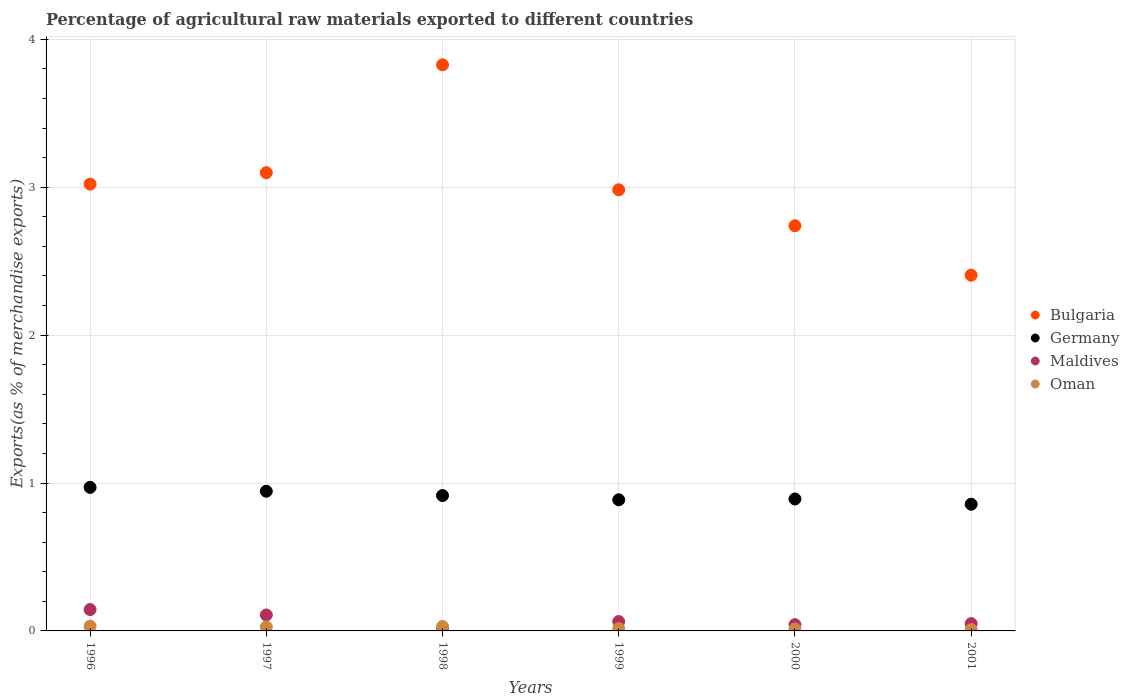How many different coloured dotlines are there?
Ensure brevity in your answer.  4. What is the percentage of exports to different countries in Maldives in 1998?
Your response must be concise. 0.01. Across all years, what is the maximum percentage of exports to different countries in Bulgaria?
Ensure brevity in your answer.  3.83. Across all years, what is the minimum percentage of exports to different countries in Oman?
Your answer should be compact. 0.01. What is the total percentage of exports to different countries in Maldives in the graph?
Offer a terse response. 0.42. What is the difference between the percentage of exports to different countries in Oman in 1996 and that in 1998?
Ensure brevity in your answer.  0. What is the difference between the percentage of exports to different countries in Maldives in 1999 and the percentage of exports to different countries in Bulgaria in 1996?
Make the answer very short. -2.96. What is the average percentage of exports to different countries in Germany per year?
Give a very brief answer. 0.91. In the year 2000, what is the difference between the percentage of exports to different countries in Oman and percentage of exports to different countries in Maldives?
Provide a succinct answer. -0.03. What is the ratio of the percentage of exports to different countries in Bulgaria in 1997 to that in 2001?
Offer a terse response. 1.29. Is the percentage of exports to different countries in Maldives in 2000 less than that in 2001?
Provide a succinct answer. Yes. Is the difference between the percentage of exports to different countries in Oman in 1998 and 2000 greater than the difference between the percentage of exports to different countries in Maldives in 1998 and 2000?
Your answer should be compact. Yes. What is the difference between the highest and the second highest percentage of exports to different countries in Bulgaria?
Keep it short and to the point. 0.73. What is the difference between the highest and the lowest percentage of exports to different countries in Bulgaria?
Your answer should be very brief. 1.42. Is it the case that in every year, the sum of the percentage of exports to different countries in Bulgaria and percentage of exports to different countries in Maldives  is greater than the sum of percentage of exports to different countries in Oman and percentage of exports to different countries in Germany?
Keep it short and to the point. Yes. Is it the case that in every year, the sum of the percentage of exports to different countries in Maldives and percentage of exports to different countries in Germany  is greater than the percentage of exports to different countries in Bulgaria?
Ensure brevity in your answer.  No. Does the percentage of exports to different countries in Germany monotonically increase over the years?
Keep it short and to the point. No. Is the percentage of exports to different countries in Maldives strictly greater than the percentage of exports to different countries in Germany over the years?
Provide a succinct answer. No. What is the difference between two consecutive major ticks on the Y-axis?
Your answer should be compact. 1. Are the values on the major ticks of Y-axis written in scientific E-notation?
Keep it short and to the point. No. Does the graph contain any zero values?
Offer a terse response. No. Where does the legend appear in the graph?
Give a very brief answer. Center right. How are the legend labels stacked?
Provide a short and direct response. Vertical. What is the title of the graph?
Offer a terse response. Percentage of agricultural raw materials exported to different countries. What is the label or title of the X-axis?
Your answer should be very brief. Years. What is the label or title of the Y-axis?
Provide a short and direct response. Exports(as % of merchandise exports). What is the Exports(as % of merchandise exports) in Bulgaria in 1996?
Ensure brevity in your answer.  3.02. What is the Exports(as % of merchandise exports) of Germany in 1996?
Provide a short and direct response. 0.97. What is the Exports(as % of merchandise exports) of Maldives in 1996?
Make the answer very short. 0.14. What is the Exports(as % of merchandise exports) in Oman in 1996?
Offer a terse response. 0.03. What is the Exports(as % of merchandise exports) of Bulgaria in 1997?
Provide a succinct answer. 3.1. What is the Exports(as % of merchandise exports) of Germany in 1997?
Keep it short and to the point. 0.94. What is the Exports(as % of merchandise exports) in Maldives in 1997?
Make the answer very short. 0.11. What is the Exports(as % of merchandise exports) in Oman in 1997?
Ensure brevity in your answer.  0.03. What is the Exports(as % of merchandise exports) in Bulgaria in 1998?
Provide a short and direct response. 3.83. What is the Exports(as % of merchandise exports) in Germany in 1998?
Offer a very short reply. 0.92. What is the Exports(as % of merchandise exports) of Maldives in 1998?
Ensure brevity in your answer.  0.01. What is the Exports(as % of merchandise exports) of Oman in 1998?
Your answer should be compact. 0.03. What is the Exports(as % of merchandise exports) in Bulgaria in 1999?
Offer a terse response. 2.98. What is the Exports(as % of merchandise exports) in Germany in 1999?
Your answer should be compact. 0.89. What is the Exports(as % of merchandise exports) in Maldives in 1999?
Offer a terse response. 0.06. What is the Exports(as % of merchandise exports) of Oman in 1999?
Ensure brevity in your answer.  0.02. What is the Exports(as % of merchandise exports) of Bulgaria in 2000?
Your response must be concise. 2.74. What is the Exports(as % of merchandise exports) of Germany in 2000?
Provide a short and direct response. 0.89. What is the Exports(as % of merchandise exports) in Maldives in 2000?
Your response must be concise. 0.04. What is the Exports(as % of merchandise exports) in Oman in 2000?
Offer a very short reply. 0.01. What is the Exports(as % of merchandise exports) in Bulgaria in 2001?
Offer a terse response. 2.41. What is the Exports(as % of merchandise exports) of Germany in 2001?
Offer a very short reply. 0.86. What is the Exports(as % of merchandise exports) in Maldives in 2001?
Your answer should be very brief. 0.05. What is the Exports(as % of merchandise exports) of Oman in 2001?
Ensure brevity in your answer.  0.01. Across all years, what is the maximum Exports(as % of merchandise exports) in Bulgaria?
Your response must be concise. 3.83. Across all years, what is the maximum Exports(as % of merchandise exports) in Germany?
Your response must be concise. 0.97. Across all years, what is the maximum Exports(as % of merchandise exports) in Maldives?
Offer a terse response. 0.14. Across all years, what is the maximum Exports(as % of merchandise exports) of Oman?
Provide a succinct answer. 0.03. Across all years, what is the minimum Exports(as % of merchandise exports) in Bulgaria?
Offer a very short reply. 2.41. Across all years, what is the minimum Exports(as % of merchandise exports) in Germany?
Provide a succinct answer. 0.86. Across all years, what is the minimum Exports(as % of merchandise exports) of Maldives?
Your response must be concise. 0.01. Across all years, what is the minimum Exports(as % of merchandise exports) of Oman?
Offer a very short reply. 0.01. What is the total Exports(as % of merchandise exports) of Bulgaria in the graph?
Keep it short and to the point. 18.07. What is the total Exports(as % of merchandise exports) of Germany in the graph?
Offer a very short reply. 5.47. What is the total Exports(as % of merchandise exports) of Maldives in the graph?
Keep it short and to the point. 0.42. What is the total Exports(as % of merchandise exports) in Oman in the graph?
Offer a very short reply. 0.13. What is the difference between the Exports(as % of merchandise exports) of Bulgaria in 1996 and that in 1997?
Keep it short and to the point. -0.08. What is the difference between the Exports(as % of merchandise exports) in Germany in 1996 and that in 1997?
Provide a succinct answer. 0.03. What is the difference between the Exports(as % of merchandise exports) in Maldives in 1996 and that in 1997?
Ensure brevity in your answer.  0.04. What is the difference between the Exports(as % of merchandise exports) in Oman in 1996 and that in 1997?
Offer a terse response. 0. What is the difference between the Exports(as % of merchandise exports) of Bulgaria in 1996 and that in 1998?
Ensure brevity in your answer.  -0.81. What is the difference between the Exports(as % of merchandise exports) in Germany in 1996 and that in 1998?
Provide a succinct answer. 0.06. What is the difference between the Exports(as % of merchandise exports) in Maldives in 1996 and that in 1998?
Provide a short and direct response. 0.13. What is the difference between the Exports(as % of merchandise exports) in Oman in 1996 and that in 1998?
Offer a terse response. 0. What is the difference between the Exports(as % of merchandise exports) of Bulgaria in 1996 and that in 1999?
Provide a succinct answer. 0.04. What is the difference between the Exports(as % of merchandise exports) of Germany in 1996 and that in 1999?
Your response must be concise. 0.08. What is the difference between the Exports(as % of merchandise exports) of Maldives in 1996 and that in 1999?
Give a very brief answer. 0.08. What is the difference between the Exports(as % of merchandise exports) in Oman in 1996 and that in 1999?
Give a very brief answer. 0.02. What is the difference between the Exports(as % of merchandise exports) in Bulgaria in 1996 and that in 2000?
Make the answer very short. 0.28. What is the difference between the Exports(as % of merchandise exports) in Germany in 1996 and that in 2000?
Ensure brevity in your answer.  0.08. What is the difference between the Exports(as % of merchandise exports) of Maldives in 1996 and that in 2000?
Keep it short and to the point. 0.1. What is the difference between the Exports(as % of merchandise exports) of Oman in 1996 and that in 2000?
Provide a short and direct response. 0.02. What is the difference between the Exports(as % of merchandise exports) in Bulgaria in 1996 and that in 2001?
Your response must be concise. 0.62. What is the difference between the Exports(as % of merchandise exports) in Germany in 1996 and that in 2001?
Provide a succinct answer. 0.11. What is the difference between the Exports(as % of merchandise exports) of Maldives in 1996 and that in 2001?
Your response must be concise. 0.1. What is the difference between the Exports(as % of merchandise exports) in Oman in 1996 and that in 2001?
Give a very brief answer. 0.02. What is the difference between the Exports(as % of merchandise exports) in Bulgaria in 1997 and that in 1998?
Give a very brief answer. -0.73. What is the difference between the Exports(as % of merchandise exports) of Germany in 1997 and that in 1998?
Keep it short and to the point. 0.03. What is the difference between the Exports(as % of merchandise exports) in Maldives in 1997 and that in 1998?
Keep it short and to the point. 0.09. What is the difference between the Exports(as % of merchandise exports) in Oman in 1997 and that in 1998?
Your answer should be compact. -0. What is the difference between the Exports(as % of merchandise exports) of Bulgaria in 1997 and that in 1999?
Your response must be concise. 0.12. What is the difference between the Exports(as % of merchandise exports) of Germany in 1997 and that in 1999?
Your answer should be compact. 0.06. What is the difference between the Exports(as % of merchandise exports) of Maldives in 1997 and that in 1999?
Keep it short and to the point. 0.04. What is the difference between the Exports(as % of merchandise exports) in Oman in 1997 and that in 1999?
Your answer should be very brief. 0.01. What is the difference between the Exports(as % of merchandise exports) in Bulgaria in 1997 and that in 2000?
Your answer should be very brief. 0.36. What is the difference between the Exports(as % of merchandise exports) of Germany in 1997 and that in 2000?
Keep it short and to the point. 0.05. What is the difference between the Exports(as % of merchandise exports) of Maldives in 1997 and that in 2000?
Your response must be concise. 0.07. What is the difference between the Exports(as % of merchandise exports) of Oman in 1997 and that in 2000?
Give a very brief answer. 0.01. What is the difference between the Exports(as % of merchandise exports) of Bulgaria in 1997 and that in 2001?
Ensure brevity in your answer.  0.69. What is the difference between the Exports(as % of merchandise exports) in Germany in 1997 and that in 2001?
Provide a succinct answer. 0.09. What is the difference between the Exports(as % of merchandise exports) of Maldives in 1997 and that in 2001?
Keep it short and to the point. 0.06. What is the difference between the Exports(as % of merchandise exports) in Oman in 1997 and that in 2001?
Ensure brevity in your answer.  0.02. What is the difference between the Exports(as % of merchandise exports) in Bulgaria in 1998 and that in 1999?
Give a very brief answer. 0.85. What is the difference between the Exports(as % of merchandise exports) in Germany in 1998 and that in 1999?
Give a very brief answer. 0.03. What is the difference between the Exports(as % of merchandise exports) of Maldives in 1998 and that in 1999?
Your response must be concise. -0.05. What is the difference between the Exports(as % of merchandise exports) of Oman in 1998 and that in 1999?
Your answer should be compact. 0.01. What is the difference between the Exports(as % of merchandise exports) in Bulgaria in 1998 and that in 2000?
Your answer should be very brief. 1.09. What is the difference between the Exports(as % of merchandise exports) of Germany in 1998 and that in 2000?
Provide a short and direct response. 0.02. What is the difference between the Exports(as % of merchandise exports) in Maldives in 1998 and that in 2000?
Provide a short and direct response. -0.03. What is the difference between the Exports(as % of merchandise exports) of Oman in 1998 and that in 2000?
Give a very brief answer. 0.02. What is the difference between the Exports(as % of merchandise exports) in Bulgaria in 1998 and that in 2001?
Provide a short and direct response. 1.42. What is the difference between the Exports(as % of merchandise exports) of Germany in 1998 and that in 2001?
Provide a short and direct response. 0.06. What is the difference between the Exports(as % of merchandise exports) of Maldives in 1998 and that in 2001?
Provide a short and direct response. -0.04. What is the difference between the Exports(as % of merchandise exports) of Oman in 1998 and that in 2001?
Your answer should be very brief. 0.02. What is the difference between the Exports(as % of merchandise exports) in Bulgaria in 1999 and that in 2000?
Give a very brief answer. 0.24. What is the difference between the Exports(as % of merchandise exports) of Germany in 1999 and that in 2000?
Provide a succinct answer. -0.01. What is the difference between the Exports(as % of merchandise exports) of Maldives in 1999 and that in 2000?
Offer a terse response. 0.02. What is the difference between the Exports(as % of merchandise exports) in Oman in 1999 and that in 2000?
Make the answer very short. 0. What is the difference between the Exports(as % of merchandise exports) in Bulgaria in 1999 and that in 2001?
Provide a short and direct response. 0.58. What is the difference between the Exports(as % of merchandise exports) of Germany in 1999 and that in 2001?
Provide a succinct answer. 0.03. What is the difference between the Exports(as % of merchandise exports) in Maldives in 1999 and that in 2001?
Provide a succinct answer. 0.01. What is the difference between the Exports(as % of merchandise exports) of Oman in 1999 and that in 2001?
Offer a very short reply. 0.01. What is the difference between the Exports(as % of merchandise exports) in Bulgaria in 2000 and that in 2001?
Provide a succinct answer. 0.33. What is the difference between the Exports(as % of merchandise exports) in Germany in 2000 and that in 2001?
Offer a very short reply. 0.04. What is the difference between the Exports(as % of merchandise exports) in Maldives in 2000 and that in 2001?
Your answer should be very brief. -0.01. What is the difference between the Exports(as % of merchandise exports) of Oman in 2000 and that in 2001?
Offer a terse response. 0. What is the difference between the Exports(as % of merchandise exports) in Bulgaria in 1996 and the Exports(as % of merchandise exports) in Germany in 1997?
Make the answer very short. 2.08. What is the difference between the Exports(as % of merchandise exports) in Bulgaria in 1996 and the Exports(as % of merchandise exports) in Maldives in 1997?
Offer a very short reply. 2.91. What is the difference between the Exports(as % of merchandise exports) in Bulgaria in 1996 and the Exports(as % of merchandise exports) in Oman in 1997?
Offer a terse response. 2.99. What is the difference between the Exports(as % of merchandise exports) in Germany in 1996 and the Exports(as % of merchandise exports) in Maldives in 1997?
Your answer should be compact. 0.86. What is the difference between the Exports(as % of merchandise exports) in Germany in 1996 and the Exports(as % of merchandise exports) in Oman in 1997?
Your response must be concise. 0.94. What is the difference between the Exports(as % of merchandise exports) of Maldives in 1996 and the Exports(as % of merchandise exports) of Oman in 1997?
Make the answer very short. 0.12. What is the difference between the Exports(as % of merchandise exports) of Bulgaria in 1996 and the Exports(as % of merchandise exports) of Germany in 1998?
Offer a terse response. 2.11. What is the difference between the Exports(as % of merchandise exports) in Bulgaria in 1996 and the Exports(as % of merchandise exports) in Maldives in 1998?
Your answer should be compact. 3.01. What is the difference between the Exports(as % of merchandise exports) in Bulgaria in 1996 and the Exports(as % of merchandise exports) in Oman in 1998?
Your answer should be compact. 2.99. What is the difference between the Exports(as % of merchandise exports) of Germany in 1996 and the Exports(as % of merchandise exports) of Maldives in 1998?
Make the answer very short. 0.96. What is the difference between the Exports(as % of merchandise exports) in Germany in 1996 and the Exports(as % of merchandise exports) in Oman in 1998?
Offer a terse response. 0.94. What is the difference between the Exports(as % of merchandise exports) in Maldives in 1996 and the Exports(as % of merchandise exports) in Oman in 1998?
Your answer should be compact. 0.11. What is the difference between the Exports(as % of merchandise exports) in Bulgaria in 1996 and the Exports(as % of merchandise exports) in Germany in 1999?
Keep it short and to the point. 2.13. What is the difference between the Exports(as % of merchandise exports) of Bulgaria in 1996 and the Exports(as % of merchandise exports) of Maldives in 1999?
Make the answer very short. 2.96. What is the difference between the Exports(as % of merchandise exports) of Bulgaria in 1996 and the Exports(as % of merchandise exports) of Oman in 1999?
Your answer should be compact. 3. What is the difference between the Exports(as % of merchandise exports) in Germany in 1996 and the Exports(as % of merchandise exports) in Maldives in 1999?
Offer a very short reply. 0.91. What is the difference between the Exports(as % of merchandise exports) in Germany in 1996 and the Exports(as % of merchandise exports) in Oman in 1999?
Provide a short and direct response. 0.95. What is the difference between the Exports(as % of merchandise exports) in Maldives in 1996 and the Exports(as % of merchandise exports) in Oman in 1999?
Make the answer very short. 0.13. What is the difference between the Exports(as % of merchandise exports) of Bulgaria in 1996 and the Exports(as % of merchandise exports) of Germany in 2000?
Offer a very short reply. 2.13. What is the difference between the Exports(as % of merchandise exports) of Bulgaria in 1996 and the Exports(as % of merchandise exports) of Maldives in 2000?
Your answer should be very brief. 2.98. What is the difference between the Exports(as % of merchandise exports) in Bulgaria in 1996 and the Exports(as % of merchandise exports) in Oman in 2000?
Give a very brief answer. 3.01. What is the difference between the Exports(as % of merchandise exports) of Germany in 1996 and the Exports(as % of merchandise exports) of Maldives in 2000?
Offer a terse response. 0.93. What is the difference between the Exports(as % of merchandise exports) in Germany in 1996 and the Exports(as % of merchandise exports) in Oman in 2000?
Make the answer very short. 0.96. What is the difference between the Exports(as % of merchandise exports) of Maldives in 1996 and the Exports(as % of merchandise exports) of Oman in 2000?
Your response must be concise. 0.13. What is the difference between the Exports(as % of merchandise exports) in Bulgaria in 1996 and the Exports(as % of merchandise exports) in Germany in 2001?
Ensure brevity in your answer.  2.16. What is the difference between the Exports(as % of merchandise exports) in Bulgaria in 1996 and the Exports(as % of merchandise exports) in Maldives in 2001?
Offer a very short reply. 2.97. What is the difference between the Exports(as % of merchandise exports) in Bulgaria in 1996 and the Exports(as % of merchandise exports) in Oman in 2001?
Make the answer very short. 3.01. What is the difference between the Exports(as % of merchandise exports) of Germany in 1996 and the Exports(as % of merchandise exports) of Maldives in 2001?
Your answer should be very brief. 0.92. What is the difference between the Exports(as % of merchandise exports) in Germany in 1996 and the Exports(as % of merchandise exports) in Oman in 2001?
Keep it short and to the point. 0.96. What is the difference between the Exports(as % of merchandise exports) of Maldives in 1996 and the Exports(as % of merchandise exports) of Oman in 2001?
Your answer should be compact. 0.14. What is the difference between the Exports(as % of merchandise exports) in Bulgaria in 1997 and the Exports(as % of merchandise exports) in Germany in 1998?
Ensure brevity in your answer.  2.18. What is the difference between the Exports(as % of merchandise exports) of Bulgaria in 1997 and the Exports(as % of merchandise exports) of Maldives in 1998?
Provide a short and direct response. 3.08. What is the difference between the Exports(as % of merchandise exports) in Bulgaria in 1997 and the Exports(as % of merchandise exports) in Oman in 1998?
Ensure brevity in your answer.  3.07. What is the difference between the Exports(as % of merchandise exports) in Germany in 1997 and the Exports(as % of merchandise exports) in Maldives in 1998?
Make the answer very short. 0.93. What is the difference between the Exports(as % of merchandise exports) of Germany in 1997 and the Exports(as % of merchandise exports) of Oman in 1998?
Make the answer very short. 0.91. What is the difference between the Exports(as % of merchandise exports) in Maldives in 1997 and the Exports(as % of merchandise exports) in Oman in 1998?
Offer a very short reply. 0.08. What is the difference between the Exports(as % of merchandise exports) of Bulgaria in 1997 and the Exports(as % of merchandise exports) of Germany in 1999?
Your answer should be very brief. 2.21. What is the difference between the Exports(as % of merchandise exports) of Bulgaria in 1997 and the Exports(as % of merchandise exports) of Maldives in 1999?
Give a very brief answer. 3.03. What is the difference between the Exports(as % of merchandise exports) of Bulgaria in 1997 and the Exports(as % of merchandise exports) of Oman in 1999?
Offer a very short reply. 3.08. What is the difference between the Exports(as % of merchandise exports) in Germany in 1997 and the Exports(as % of merchandise exports) in Maldives in 1999?
Make the answer very short. 0.88. What is the difference between the Exports(as % of merchandise exports) in Germany in 1997 and the Exports(as % of merchandise exports) in Oman in 1999?
Give a very brief answer. 0.93. What is the difference between the Exports(as % of merchandise exports) in Maldives in 1997 and the Exports(as % of merchandise exports) in Oman in 1999?
Offer a very short reply. 0.09. What is the difference between the Exports(as % of merchandise exports) of Bulgaria in 1997 and the Exports(as % of merchandise exports) of Germany in 2000?
Your answer should be compact. 2.21. What is the difference between the Exports(as % of merchandise exports) of Bulgaria in 1997 and the Exports(as % of merchandise exports) of Maldives in 2000?
Make the answer very short. 3.06. What is the difference between the Exports(as % of merchandise exports) of Bulgaria in 1997 and the Exports(as % of merchandise exports) of Oman in 2000?
Offer a very short reply. 3.08. What is the difference between the Exports(as % of merchandise exports) of Germany in 1997 and the Exports(as % of merchandise exports) of Maldives in 2000?
Keep it short and to the point. 0.9. What is the difference between the Exports(as % of merchandise exports) of Germany in 1997 and the Exports(as % of merchandise exports) of Oman in 2000?
Make the answer very short. 0.93. What is the difference between the Exports(as % of merchandise exports) in Maldives in 1997 and the Exports(as % of merchandise exports) in Oman in 2000?
Ensure brevity in your answer.  0.09. What is the difference between the Exports(as % of merchandise exports) in Bulgaria in 1997 and the Exports(as % of merchandise exports) in Germany in 2001?
Ensure brevity in your answer.  2.24. What is the difference between the Exports(as % of merchandise exports) in Bulgaria in 1997 and the Exports(as % of merchandise exports) in Maldives in 2001?
Keep it short and to the point. 3.05. What is the difference between the Exports(as % of merchandise exports) in Bulgaria in 1997 and the Exports(as % of merchandise exports) in Oman in 2001?
Your response must be concise. 3.09. What is the difference between the Exports(as % of merchandise exports) in Germany in 1997 and the Exports(as % of merchandise exports) in Maldives in 2001?
Provide a short and direct response. 0.9. What is the difference between the Exports(as % of merchandise exports) in Germany in 1997 and the Exports(as % of merchandise exports) in Oman in 2001?
Your response must be concise. 0.94. What is the difference between the Exports(as % of merchandise exports) in Maldives in 1997 and the Exports(as % of merchandise exports) in Oman in 2001?
Your answer should be compact. 0.1. What is the difference between the Exports(as % of merchandise exports) in Bulgaria in 1998 and the Exports(as % of merchandise exports) in Germany in 1999?
Give a very brief answer. 2.94. What is the difference between the Exports(as % of merchandise exports) of Bulgaria in 1998 and the Exports(as % of merchandise exports) of Maldives in 1999?
Keep it short and to the point. 3.76. What is the difference between the Exports(as % of merchandise exports) in Bulgaria in 1998 and the Exports(as % of merchandise exports) in Oman in 1999?
Ensure brevity in your answer.  3.81. What is the difference between the Exports(as % of merchandise exports) in Germany in 1998 and the Exports(as % of merchandise exports) in Maldives in 1999?
Provide a short and direct response. 0.85. What is the difference between the Exports(as % of merchandise exports) of Germany in 1998 and the Exports(as % of merchandise exports) of Oman in 1999?
Give a very brief answer. 0.9. What is the difference between the Exports(as % of merchandise exports) in Maldives in 1998 and the Exports(as % of merchandise exports) in Oman in 1999?
Ensure brevity in your answer.  -0. What is the difference between the Exports(as % of merchandise exports) of Bulgaria in 1998 and the Exports(as % of merchandise exports) of Germany in 2000?
Ensure brevity in your answer.  2.94. What is the difference between the Exports(as % of merchandise exports) of Bulgaria in 1998 and the Exports(as % of merchandise exports) of Maldives in 2000?
Your answer should be compact. 3.79. What is the difference between the Exports(as % of merchandise exports) in Bulgaria in 1998 and the Exports(as % of merchandise exports) in Oman in 2000?
Offer a terse response. 3.81. What is the difference between the Exports(as % of merchandise exports) of Germany in 1998 and the Exports(as % of merchandise exports) of Maldives in 2000?
Make the answer very short. 0.87. What is the difference between the Exports(as % of merchandise exports) in Germany in 1998 and the Exports(as % of merchandise exports) in Oman in 2000?
Provide a short and direct response. 0.9. What is the difference between the Exports(as % of merchandise exports) of Maldives in 1998 and the Exports(as % of merchandise exports) of Oman in 2000?
Your answer should be compact. -0. What is the difference between the Exports(as % of merchandise exports) in Bulgaria in 1998 and the Exports(as % of merchandise exports) in Germany in 2001?
Your response must be concise. 2.97. What is the difference between the Exports(as % of merchandise exports) in Bulgaria in 1998 and the Exports(as % of merchandise exports) in Maldives in 2001?
Your answer should be compact. 3.78. What is the difference between the Exports(as % of merchandise exports) of Bulgaria in 1998 and the Exports(as % of merchandise exports) of Oman in 2001?
Provide a short and direct response. 3.82. What is the difference between the Exports(as % of merchandise exports) in Germany in 1998 and the Exports(as % of merchandise exports) in Maldives in 2001?
Make the answer very short. 0.87. What is the difference between the Exports(as % of merchandise exports) in Germany in 1998 and the Exports(as % of merchandise exports) in Oman in 2001?
Give a very brief answer. 0.91. What is the difference between the Exports(as % of merchandise exports) of Maldives in 1998 and the Exports(as % of merchandise exports) of Oman in 2001?
Your response must be concise. 0. What is the difference between the Exports(as % of merchandise exports) of Bulgaria in 1999 and the Exports(as % of merchandise exports) of Germany in 2000?
Ensure brevity in your answer.  2.09. What is the difference between the Exports(as % of merchandise exports) in Bulgaria in 1999 and the Exports(as % of merchandise exports) in Maldives in 2000?
Ensure brevity in your answer.  2.94. What is the difference between the Exports(as % of merchandise exports) of Bulgaria in 1999 and the Exports(as % of merchandise exports) of Oman in 2000?
Keep it short and to the point. 2.97. What is the difference between the Exports(as % of merchandise exports) of Germany in 1999 and the Exports(as % of merchandise exports) of Maldives in 2000?
Your answer should be compact. 0.84. What is the difference between the Exports(as % of merchandise exports) of Germany in 1999 and the Exports(as % of merchandise exports) of Oman in 2000?
Provide a succinct answer. 0.87. What is the difference between the Exports(as % of merchandise exports) in Maldives in 1999 and the Exports(as % of merchandise exports) in Oman in 2000?
Ensure brevity in your answer.  0.05. What is the difference between the Exports(as % of merchandise exports) in Bulgaria in 1999 and the Exports(as % of merchandise exports) in Germany in 2001?
Provide a short and direct response. 2.13. What is the difference between the Exports(as % of merchandise exports) in Bulgaria in 1999 and the Exports(as % of merchandise exports) in Maldives in 2001?
Keep it short and to the point. 2.93. What is the difference between the Exports(as % of merchandise exports) of Bulgaria in 1999 and the Exports(as % of merchandise exports) of Oman in 2001?
Provide a short and direct response. 2.97. What is the difference between the Exports(as % of merchandise exports) in Germany in 1999 and the Exports(as % of merchandise exports) in Maldives in 2001?
Give a very brief answer. 0.84. What is the difference between the Exports(as % of merchandise exports) in Germany in 1999 and the Exports(as % of merchandise exports) in Oman in 2001?
Provide a short and direct response. 0.88. What is the difference between the Exports(as % of merchandise exports) of Maldives in 1999 and the Exports(as % of merchandise exports) of Oman in 2001?
Offer a very short reply. 0.05. What is the difference between the Exports(as % of merchandise exports) of Bulgaria in 2000 and the Exports(as % of merchandise exports) of Germany in 2001?
Your answer should be compact. 1.88. What is the difference between the Exports(as % of merchandise exports) of Bulgaria in 2000 and the Exports(as % of merchandise exports) of Maldives in 2001?
Offer a very short reply. 2.69. What is the difference between the Exports(as % of merchandise exports) of Bulgaria in 2000 and the Exports(as % of merchandise exports) of Oman in 2001?
Provide a succinct answer. 2.73. What is the difference between the Exports(as % of merchandise exports) of Germany in 2000 and the Exports(as % of merchandise exports) of Maldives in 2001?
Provide a short and direct response. 0.84. What is the difference between the Exports(as % of merchandise exports) of Germany in 2000 and the Exports(as % of merchandise exports) of Oman in 2001?
Your answer should be very brief. 0.88. What is the difference between the Exports(as % of merchandise exports) of Maldives in 2000 and the Exports(as % of merchandise exports) of Oman in 2001?
Your answer should be compact. 0.03. What is the average Exports(as % of merchandise exports) in Bulgaria per year?
Give a very brief answer. 3.01. What is the average Exports(as % of merchandise exports) of Germany per year?
Give a very brief answer. 0.91. What is the average Exports(as % of merchandise exports) of Maldives per year?
Ensure brevity in your answer.  0.07. What is the average Exports(as % of merchandise exports) of Oman per year?
Keep it short and to the point. 0.02. In the year 1996, what is the difference between the Exports(as % of merchandise exports) in Bulgaria and Exports(as % of merchandise exports) in Germany?
Keep it short and to the point. 2.05. In the year 1996, what is the difference between the Exports(as % of merchandise exports) in Bulgaria and Exports(as % of merchandise exports) in Maldives?
Ensure brevity in your answer.  2.88. In the year 1996, what is the difference between the Exports(as % of merchandise exports) of Bulgaria and Exports(as % of merchandise exports) of Oman?
Offer a terse response. 2.99. In the year 1996, what is the difference between the Exports(as % of merchandise exports) in Germany and Exports(as % of merchandise exports) in Maldives?
Your answer should be compact. 0.83. In the year 1996, what is the difference between the Exports(as % of merchandise exports) in Germany and Exports(as % of merchandise exports) in Oman?
Ensure brevity in your answer.  0.94. In the year 1996, what is the difference between the Exports(as % of merchandise exports) in Maldives and Exports(as % of merchandise exports) in Oman?
Keep it short and to the point. 0.11. In the year 1997, what is the difference between the Exports(as % of merchandise exports) in Bulgaria and Exports(as % of merchandise exports) in Germany?
Provide a succinct answer. 2.15. In the year 1997, what is the difference between the Exports(as % of merchandise exports) in Bulgaria and Exports(as % of merchandise exports) in Maldives?
Your response must be concise. 2.99. In the year 1997, what is the difference between the Exports(as % of merchandise exports) in Bulgaria and Exports(as % of merchandise exports) in Oman?
Your answer should be very brief. 3.07. In the year 1997, what is the difference between the Exports(as % of merchandise exports) in Germany and Exports(as % of merchandise exports) in Maldives?
Your answer should be very brief. 0.84. In the year 1997, what is the difference between the Exports(as % of merchandise exports) of Germany and Exports(as % of merchandise exports) of Oman?
Make the answer very short. 0.92. In the year 1997, what is the difference between the Exports(as % of merchandise exports) of Maldives and Exports(as % of merchandise exports) of Oman?
Give a very brief answer. 0.08. In the year 1998, what is the difference between the Exports(as % of merchandise exports) of Bulgaria and Exports(as % of merchandise exports) of Germany?
Your response must be concise. 2.91. In the year 1998, what is the difference between the Exports(as % of merchandise exports) in Bulgaria and Exports(as % of merchandise exports) in Maldives?
Make the answer very short. 3.81. In the year 1998, what is the difference between the Exports(as % of merchandise exports) of Bulgaria and Exports(as % of merchandise exports) of Oman?
Make the answer very short. 3.8. In the year 1998, what is the difference between the Exports(as % of merchandise exports) of Germany and Exports(as % of merchandise exports) of Maldives?
Provide a succinct answer. 0.9. In the year 1998, what is the difference between the Exports(as % of merchandise exports) in Germany and Exports(as % of merchandise exports) in Oman?
Provide a succinct answer. 0.89. In the year 1998, what is the difference between the Exports(as % of merchandise exports) of Maldives and Exports(as % of merchandise exports) of Oman?
Your answer should be compact. -0.02. In the year 1999, what is the difference between the Exports(as % of merchandise exports) of Bulgaria and Exports(as % of merchandise exports) of Germany?
Keep it short and to the point. 2.1. In the year 1999, what is the difference between the Exports(as % of merchandise exports) in Bulgaria and Exports(as % of merchandise exports) in Maldives?
Ensure brevity in your answer.  2.92. In the year 1999, what is the difference between the Exports(as % of merchandise exports) of Bulgaria and Exports(as % of merchandise exports) of Oman?
Make the answer very short. 2.97. In the year 1999, what is the difference between the Exports(as % of merchandise exports) in Germany and Exports(as % of merchandise exports) in Maldives?
Your response must be concise. 0.82. In the year 1999, what is the difference between the Exports(as % of merchandise exports) of Germany and Exports(as % of merchandise exports) of Oman?
Make the answer very short. 0.87. In the year 1999, what is the difference between the Exports(as % of merchandise exports) in Maldives and Exports(as % of merchandise exports) in Oman?
Your answer should be very brief. 0.05. In the year 2000, what is the difference between the Exports(as % of merchandise exports) of Bulgaria and Exports(as % of merchandise exports) of Germany?
Offer a very short reply. 1.85. In the year 2000, what is the difference between the Exports(as % of merchandise exports) of Bulgaria and Exports(as % of merchandise exports) of Maldives?
Your answer should be compact. 2.7. In the year 2000, what is the difference between the Exports(as % of merchandise exports) in Bulgaria and Exports(as % of merchandise exports) in Oman?
Make the answer very short. 2.73. In the year 2000, what is the difference between the Exports(as % of merchandise exports) in Germany and Exports(as % of merchandise exports) in Maldives?
Offer a very short reply. 0.85. In the year 2000, what is the difference between the Exports(as % of merchandise exports) of Germany and Exports(as % of merchandise exports) of Oman?
Provide a succinct answer. 0.88. In the year 2000, what is the difference between the Exports(as % of merchandise exports) in Maldives and Exports(as % of merchandise exports) in Oman?
Provide a short and direct response. 0.03. In the year 2001, what is the difference between the Exports(as % of merchandise exports) of Bulgaria and Exports(as % of merchandise exports) of Germany?
Offer a terse response. 1.55. In the year 2001, what is the difference between the Exports(as % of merchandise exports) in Bulgaria and Exports(as % of merchandise exports) in Maldives?
Your answer should be very brief. 2.36. In the year 2001, what is the difference between the Exports(as % of merchandise exports) of Bulgaria and Exports(as % of merchandise exports) of Oman?
Ensure brevity in your answer.  2.4. In the year 2001, what is the difference between the Exports(as % of merchandise exports) of Germany and Exports(as % of merchandise exports) of Maldives?
Offer a terse response. 0.81. In the year 2001, what is the difference between the Exports(as % of merchandise exports) in Germany and Exports(as % of merchandise exports) in Oman?
Offer a very short reply. 0.85. In the year 2001, what is the difference between the Exports(as % of merchandise exports) of Maldives and Exports(as % of merchandise exports) of Oman?
Give a very brief answer. 0.04. What is the ratio of the Exports(as % of merchandise exports) of Bulgaria in 1996 to that in 1997?
Ensure brevity in your answer.  0.98. What is the ratio of the Exports(as % of merchandise exports) in Germany in 1996 to that in 1997?
Your response must be concise. 1.03. What is the ratio of the Exports(as % of merchandise exports) of Maldives in 1996 to that in 1997?
Your answer should be compact. 1.34. What is the ratio of the Exports(as % of merchandise exports) in Oman in 1996 to that in 1997?
Keep it short and to the point. 1.18. What is the ratio of the Exports(as % of merchandise exports) in Bulgaria in 1996 to that in 1998?
Offer a terse response. 0.79. What is the ratio of the Exports(as % of merchandise exports) in Germany in 1996 to that in 1998?
Provide a succinct answer. 1.06. What is the ratio of the Exports(as % of merchandise exports) of Maldives in 1996 to that in 1998?
Give a very brief answer. 10.48. What is the ratio of the Exports(as % of merchandise exports) of Oman in 1996 to that in 1998?
Provide a succinct answer. 1.06. What is the ratio of the Exports(as % of merchandise exports) of Bulgaria in 1996 to that in 1999?
Your answer should be very brief. 1.01. What is the ratio of the Exports(as % of merchandise exports) of Germany in 1996 to that in 1999?
Your answer should be very brief. 1.09. What is the ratio of the Exports(as % of merchandise exports) of Maldives in 1996 to that in 1999?
Offer a terse response. 2.28. What is the ratio of the Exports(as % of merchandise exports) of Oman in 1996 to that in 1999?
Make the answer very short. 2. What is the ratio of the Exports(as % of merchandise exports) of Bulgaria in 1996 to that in 2000?
Your answer should be compact. 1.1. What is the ratio of the Exports(as % of merchandise exports) of Germany in 1996 to that in 2000?
Give a very brief answer. 1.09. What is the ratio of the Exports(as % of merchandise exports) of Maldives in 1996 to that in 2000?
Offer a terse response. 3.41. What is the ratio of the Exports(as % of merchandise exports) of Oman in 1996 to that in 2000?
Offer a very short reply. 2.3. What is the ratio of the Exports(as % of merchandise exports) in Bulgaria in 1996 to that in 2001?
Your answer should be compact. 1.26. What is the ratio of the Exports(as % of merchandise exports) in Germany in 1996 to that in 2001?
Offer a very short reply. 1.13. What is the ratio of the Exports(as % of merchandise exports) of Maldives in 1996 to that in 2001?
Keep it short and to the point. 2.92. What is the ratio of the Exports(as % of merchandise exports) in Oman in 1996 to that in 2001?
Your answer should be compact. 3.47. What is the ratio of the Exports(as % of merchandise exports) in Bulgaria in 1997 to that in 1998?
Offer a terse response. 0.81. What is the ratio of the Exports(as % of merchandise exports) in Germany in 1997 to that in 1998?
Your answer should be very brief. 1.03. What is the ratio of the Exports(as % of merchandise exports) in Maldives in 1997 to that in 1998?
Give a very brief answer. 7.83. What is the ratio of the Exports(as % of merchandise exports) in Oman in 1997 to that in 1998?
Provide a short and direct response. 0.9. What is the ratio of the Exports(as % of merchandise exports) in Bulgaria in 1997 to that in 1999?
Your response must be concise. 1.04. What is the ratio of the Exports(as % of merchandise exports) in Germany in 1997 to that in 1999?
Make the answer very short. 1.06. What is the ratio of the Exports(as % of merchandise exports) of Maldives in 1997 to that in 1999?
Your response must be concise. 1.7. What is the ratio of the Exports(as % of merchandise exports) of Oman in 1997 to that in 1999?
Give a very brief answer. 1.7. What is the ratio of the Exports(as % of merchandise exports) in Bulgaria in 1997 to that in 2000?
Offer a very short reply. 1.13. What is the ratio of the Exports(as % of merchandise exports) of Germany in 1997 to that in 2000?
Provide a short and direct response. 1.06. What is the ratio of the Exports(as % of merchandise exports) in Maldives in 1997 to that in 2000?
Make the answer very short. 2.55. What is the ratio of the Exports(as % of merchandise exports) of Oman in 1997 to that in 2000?
Give a very brief answer. 1.95. What is the ratio of the Exports(as % of merchandise exports) of Bulgaria in 1997 to that in 2001?
Provide a succinct answer. 1.29. What is the ratio of the Exports(as % of merchandise exports) in Germany in 1997 to that in 2001?
Your answer should be compact. 1.1. What is the ratio of the Exports(as % of merchandise exports) of Maldives in 1997 to that in 2001?
Your answer should be compact. 2.18. What is the ratio of the Exports(as % of merchandise exports) in Oman in 1997 to that in 2001?
Provide a short and direct response. 2.95. What is the ratio of the Exports(as % of merchandise exports) in Bulgaria in 1998 to that in 1999?
Your answer should be compact. 1.28. What is the ratio of the Exports(as % of merchandise exports) in Germany in 1998 to that in 1999?
Provide a succinct answer. 1.03. What is the ratio of the Exports(as % of merchandise exports) in Maldives in 1998 to that in 1999?
Your answer should be very brief. 0.22. What is the ratio of the Exports(as % of merchandise exports) of Oman in 1998 to that in 1999?
Provide a succinct answer. 1.89. What is the ratio of the Exports(as % of merchandise exports) of Bulgaria in 1998 to that in 2000?
Offer a terse response. 1.4. What is the ratio of the Exports(as % of merchandise exports) of Maldives in 1998 to that in 2000?
Ensure brevity in your answer.  0.33. What is the ratio of the Exports(as % of merchandise exports) of Oman in 1998 to that in 2000?
Keep it short and to the point. 2.17. What is the ratio of the Exports(as % of merchandise exports) in Bulgaria in 1998 to that in 2001?
Provide a succinct answer. 1.59. What is the ratio of the Exports(as % of merchandise exports) of Germany in 1998 to that in 2001?
Your response must be concise. 1.07. What is the ratio of the Exports(as % of merchandise exports) in Maldives in 1998 to that in 2001?
Your answer should be very brief. 0.28. What is the ratio of the Exports(as % of merchandise exports) in Oman in 1998 to that in 2001?
Your response must be concise. 3.28. What is the ratio of the Exports(as % of merchandise exports) of Bulgaria in 1999 to that in 2000?
Make the answer very short. 1.09. What is the ratio of the Exports(as % of merchandise exports) of Germany in 1999 to that in 2000?
Offer a very short reply. 0.99. What is the ratio of the Exports(as % of merchandise exports) of Maldives in 1999 to that in 2000?
Provide a succinct answer. 1.5. What is the ratio of the Exports(as % of merchandise exports) in Oman in 1999 to that in 2000?
Keep it short and to the point. 1.15. What is the ratio of the Exports(as % of merchandise exports) in Bulgaria in 1999 to that in 2001?
Provide a short and direct response. 1.24. What is the ratio of the Exports(as % of merchandise exports) of Germany in 1999 to that in 2001?
Offer a terse response. 1.04. What is the ratio of the Exports(as % of merchandise exports) of Maldives in 1999 to that in 2001?
Offer a terse response. 1.28. What is the ratio of the Exports(as % of merchandise exports) in Oman in 1999 to that in 2001?
Provide a succinct answer. 1.73. What is the ratio of the Exports(as % of merchandise exports) in Bulgaria in 2000 to that in 2001?
Make the answer very short. 1.14. What is the ratio of the Exports(as % of merchandise exports) of Germany in 2000 to that in 2001?
Offer a terse response. 1.04. What is the ratio of the Exports(as % of merchandise exports) of Maldives in 2000 to that in 2001?
Offer a terse response. 0.86. What is the ratio of the Exports(as % of merchandise exports) of Oman in 2000 to that in 2001?
Your answer should be compact. 1.51. What is the difference between the highest and the second highest Exports(as % of merchandise exports) in Bulgaria?
Keep it short and to the point. 0.73. What is the difference between the highest and the second highest Exports(as % of merchandise exports) of Germany?
Provide a short and direct response. 0.03. What is the difference between the highest and the second highest Exports(as % of merchandise exports) in Maldives?
Make the answer very short. 0.04. What is the difference between the highest and the second highest Exports(as % of merchandise exports) of Oman?
Keep it short and to the point. 0. What is the difference between the highest and the lowest Exports(as % of merchandise exports) in Bulgaria?
Your answer should be very brief. 1.42. What is the difference between the highest and the lowest Exports(as % of merchandise exports) in Germany?
Your answer should be very brief. 0.11. What is the difference between the highest and the lowest Exports(as % of merchandise exports) in Maldives?
Your response must be concise. 0.13. What is the difference between the highest and the lowest Exports(as % of merchandise exports) in Oman?
Provide a short and direct response. 0.02. 